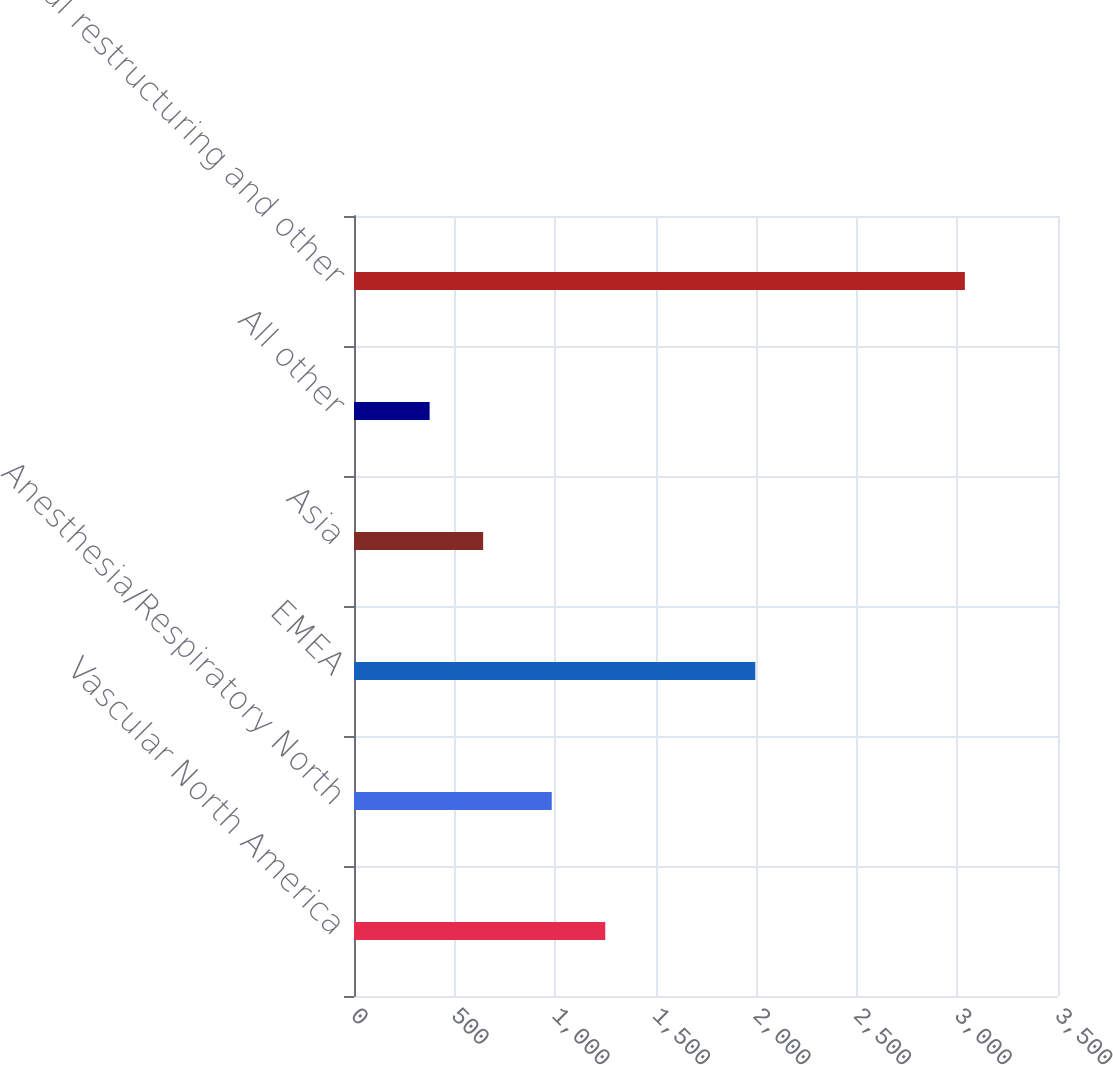Convert chart. <chart><loc_0><loc_0><loc_500><loc_500><bar_chart><fcel>Vascular North America<fcel>Anesthesia/Respiratory North<fcel>EMEA<fcel>Asia<fcel>All other<fcel>Total restructuring and other<nl><fcel>1249.1<fcel>983<fcel>1995<fcel>642.1<fcel>376<fcel>3037<nl></chart> 